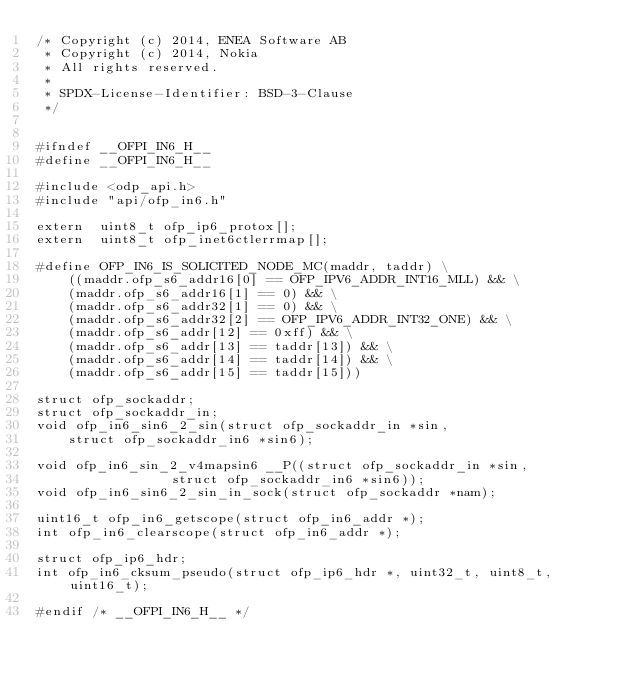<code> <loc_0><loc_0><loc_500><loc_500><_C_>/* Copyright (c) 2014, ENEA Software AB
 * Copyright (c) 2014, Nokia
 * All rights reserved.
 *
 * SPDX-License-Identifier:	BSD-3-Clause
 */


#ifndef __OFPI_IN6_H__
#define __OFPI_IN6_H__

#include <odp_api.h>
#include "api/ofp_in6.h"

extern  uint8_t ofp_ip6_protox[];
extern  uint8_t ofp_inet6ctlerrmap[];

#define OFP_IN6_IS_SOLICITED_NODE_MC(maddr, taddr) \
	((maddr.ofp_s6_addr16[0] == OFP_IPV6_ADDR_INT16_MLL) && \
	(maddr.ofp_s6_addr16[1] == 0) && \
	(maddr.ofp_s6_addr32[1] == 0) && \
	(maddr.ofp_s6_addr32[2] == OFP_IPV6_ADDR_INT32_ONE) && \
	(maddr.ofp_s6_addr[12] == 0xff) && \
	(maddr.ofp_s6_addr[13] == taddr[13]) && \
	(maddr.ofp_s6_addr[14] == taddr[14]) && \
	(maddr.ofp_s6_addr[15] == taddr[15]))

struct ofp_sockaddr;
struct ofp_sockaddr_in;
void ofp_in6_sin6_2_sin(struct ofp_sockaddr_in *sin,
	struct ofp_sockaddr_in6 *sin6);

void ofp_in6_sin_2_v4mapsin6 __P((struct ofp_sockaddr_in *sin,
				 struct ofp_sockaddr_in6 *sin6));
void ofp_in6_sin6_2_sin_in_sock(struct ofp_sockaddr *nam);

uint16_t ofp_in6_getscope(struct ofp_in6_addr *);
int ofp_in6_clearscope(struct ofp_in6_addr *);

struct ofp_ip6_hdr;
int ofp_in6_cksum_pseudo(struct ofp_ip6_hdr *, uint32_t, uint8_t, uint16_t);

#endif /* __OFPI_IN6_H__ */
</code> 